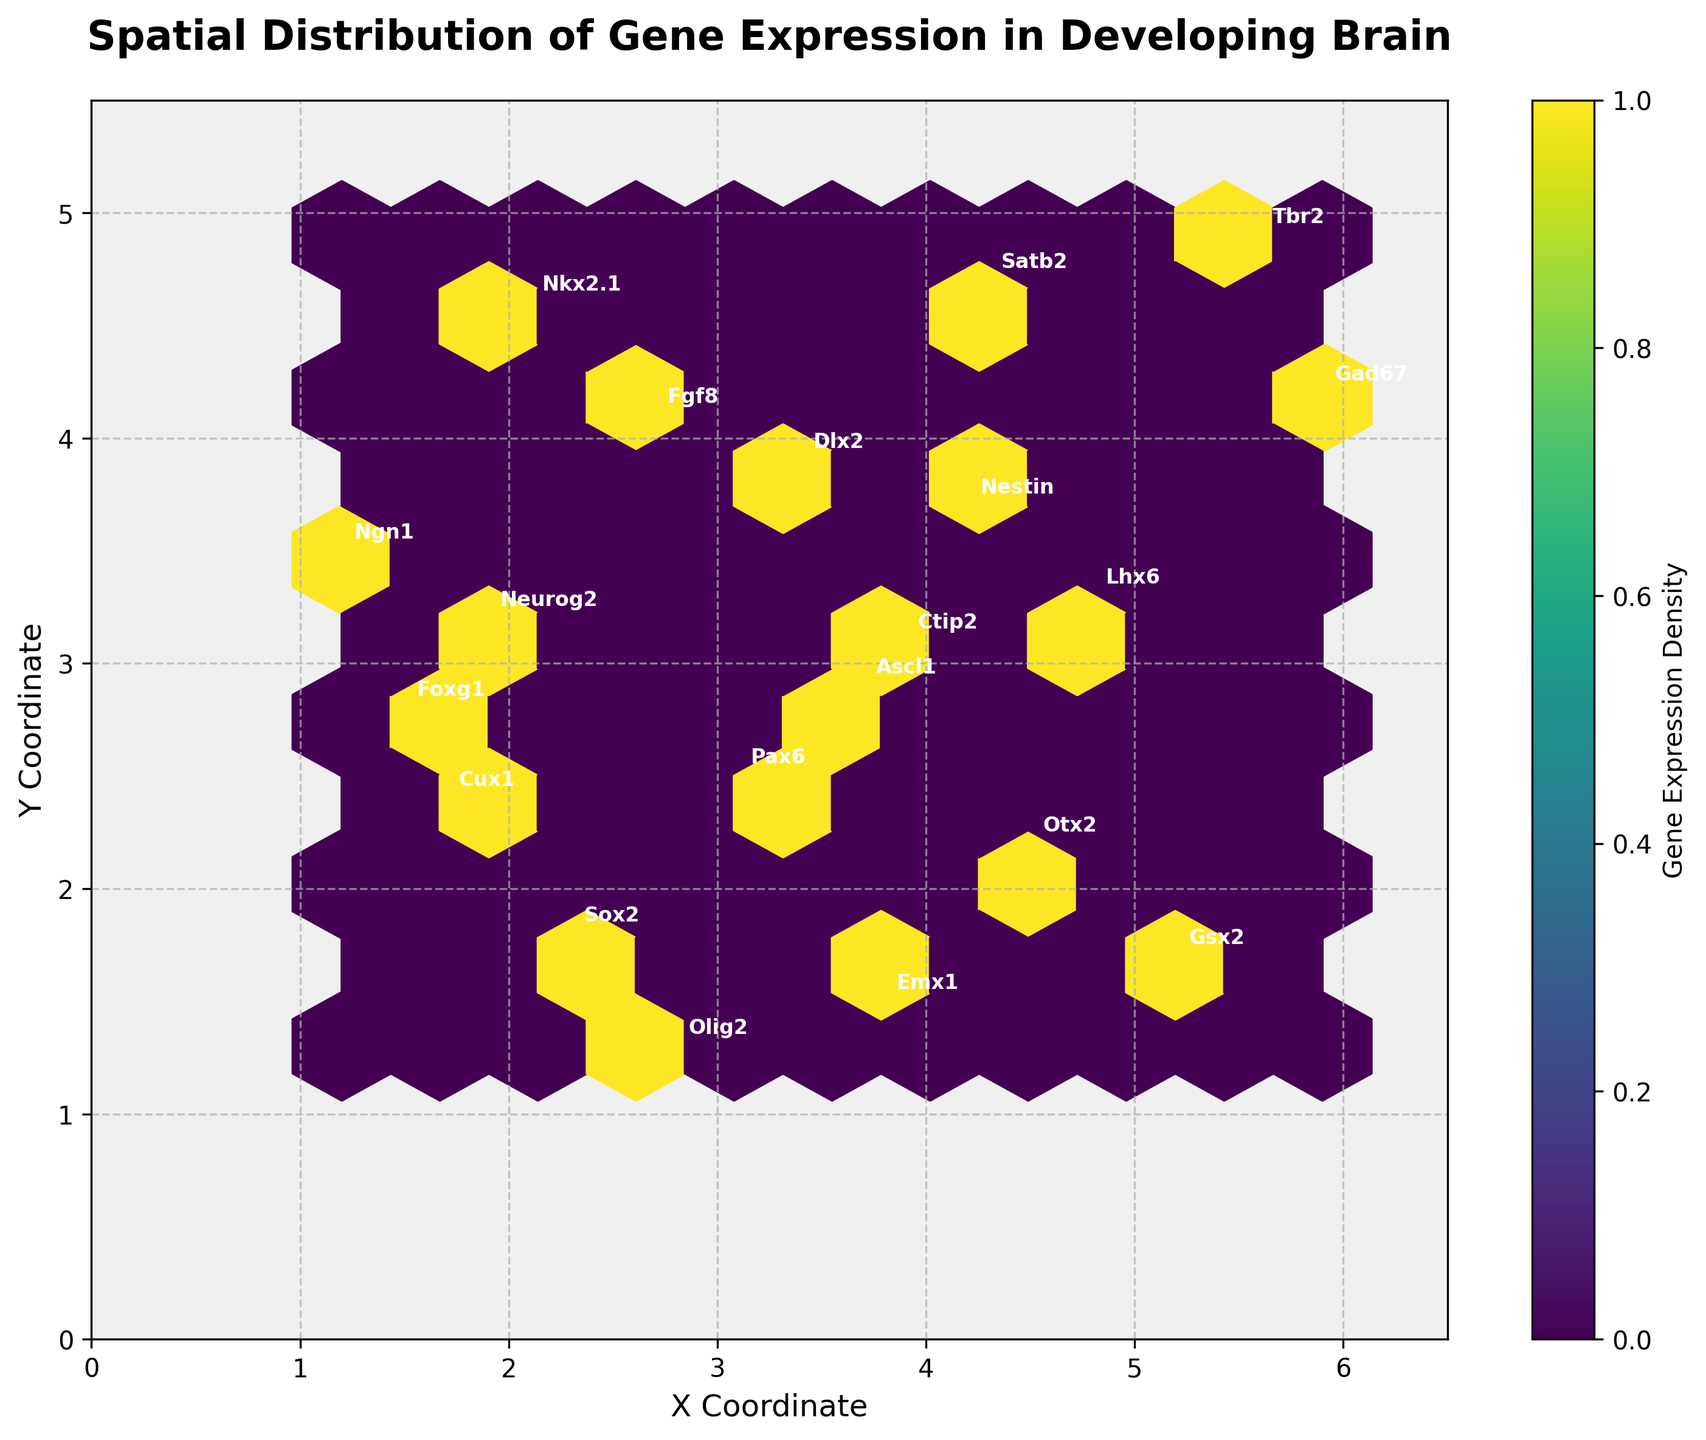How many hexagons are there in the plot? To count the hexagons, one should look at the overall grid structure in the plot and simply count the number of hexagons shown.
Answer: 10 Which gene expression is located at the highest y-coordinate? By identifying the y-coordinates in the plot, one should look at the topmost labeled gene expression. The label annotated at the highest y-coordinate will be evident.
Answer: Nkx2.1 What is the color of the hexbin with the highest gene expression density? Observing the color scale of the plot, the hexbin with the deepest shade (likely dark purple) will have the highest density.
Answer: Dark purple Which coordinate has the highest density of gene expressions? By referring to the color intensity of the hexagons, the hexbin with the darkest color represents the highest density. Generally, visual inspection helps find this region.
Answer: Near (3, 3) Is the gene expression "Otx2" located more towards the left or the right side of the x-axis? By locating "Otx2" in the plot and comparing its x-coordinate with the middle of the axis (approximately 3.25), it can be determined whether it's more to the left or right.
Answer: Right What is the range of x-coordinates shown in the plot? Observing the x-axis limits in the plot, one can directly see the minimum and maximum values of the x-axis.
Answer: 0 to 6.5 Which gene expressions are labeled within the densest hexagon? Identifying the densest hexagon (darkest color) and checking the labels within or near this hexagon, one can determine the gene expressions falling within it.
Answer: Emx1, Dlx2, Otx2, Ascl1 How does the density change from left to right on the plot? By observing the color gradient of the hexagons from the left side to the right side, one can describe the overall trend in density.
Answer: Increases, peaking around the center How many genes are expressed at y-coordinates greater than 4? Counting the labels of gene expressions located above the y-value of 4 in the plot provides the answer.
Answer: 4 (Nkx2.1, Nestin, Fgf8, Gad67) What is the relationship between the x and y coordinates for the label "Ctip2"? Identifying the coordinates from the annotation of "Ctip2" and comparing x and y values reveals their relationship.
Answer: X is greater than Y 